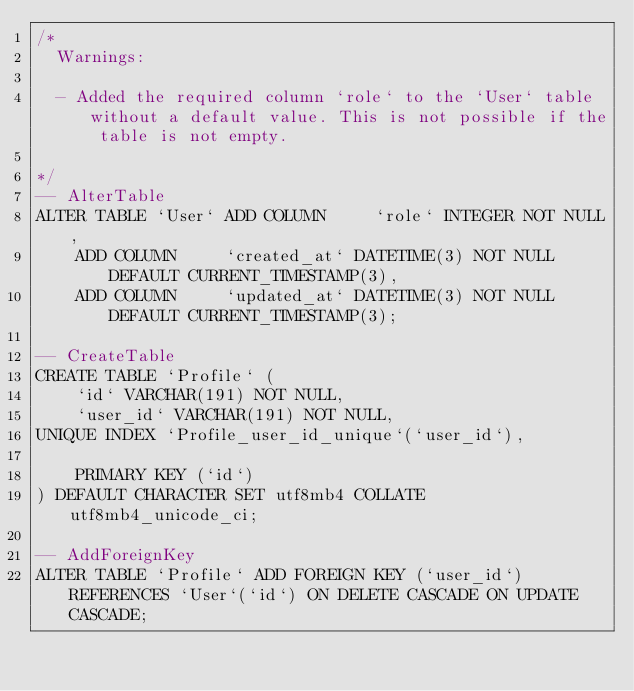Convert code to text. <code><loc_0><loc_0><loc_500><loc_500><_SQL_>/*
  Warnings:

  - Added the required column `role` to the `User` table without a default value. This is not possible if the table is not empty.

*/
-- AlterTable
ALTER TABLE `User` ADD COLUMN     `role` INTEGER NOT NULL,
    ADD COLUMN     `created_at` DATETIME(3) NOT NULL DEFAULT CURRENT_TIMESTAMP(3),
    ADD COLUMN     `updated_at` DATETIME(3) NOT NULL DEFAULT CURRENT_TIMESTAMP(3);

-- CreateTable
CREATE TABLE `Profile` (
    `id` VARCHAR(191) NOT NULL,
    `user_id` VARCHAR(191) NOT NULL,
UNIQUE INDEX `Profile_user_id_unique`(`user_id`),

    PRIMARY KEY (`id`)
) DEFAULT CHARACTER SET utf8mb4 COLLATE utf8mb4_unicode_ci;

-- AddForeignKey
ALTER TABLE `Profile` ADD FOREIGN KEY (`user_id`) REFERENCES `User`(`id`) ON DELETE CASCADE ON UPDATE CASCADE;
</code> 